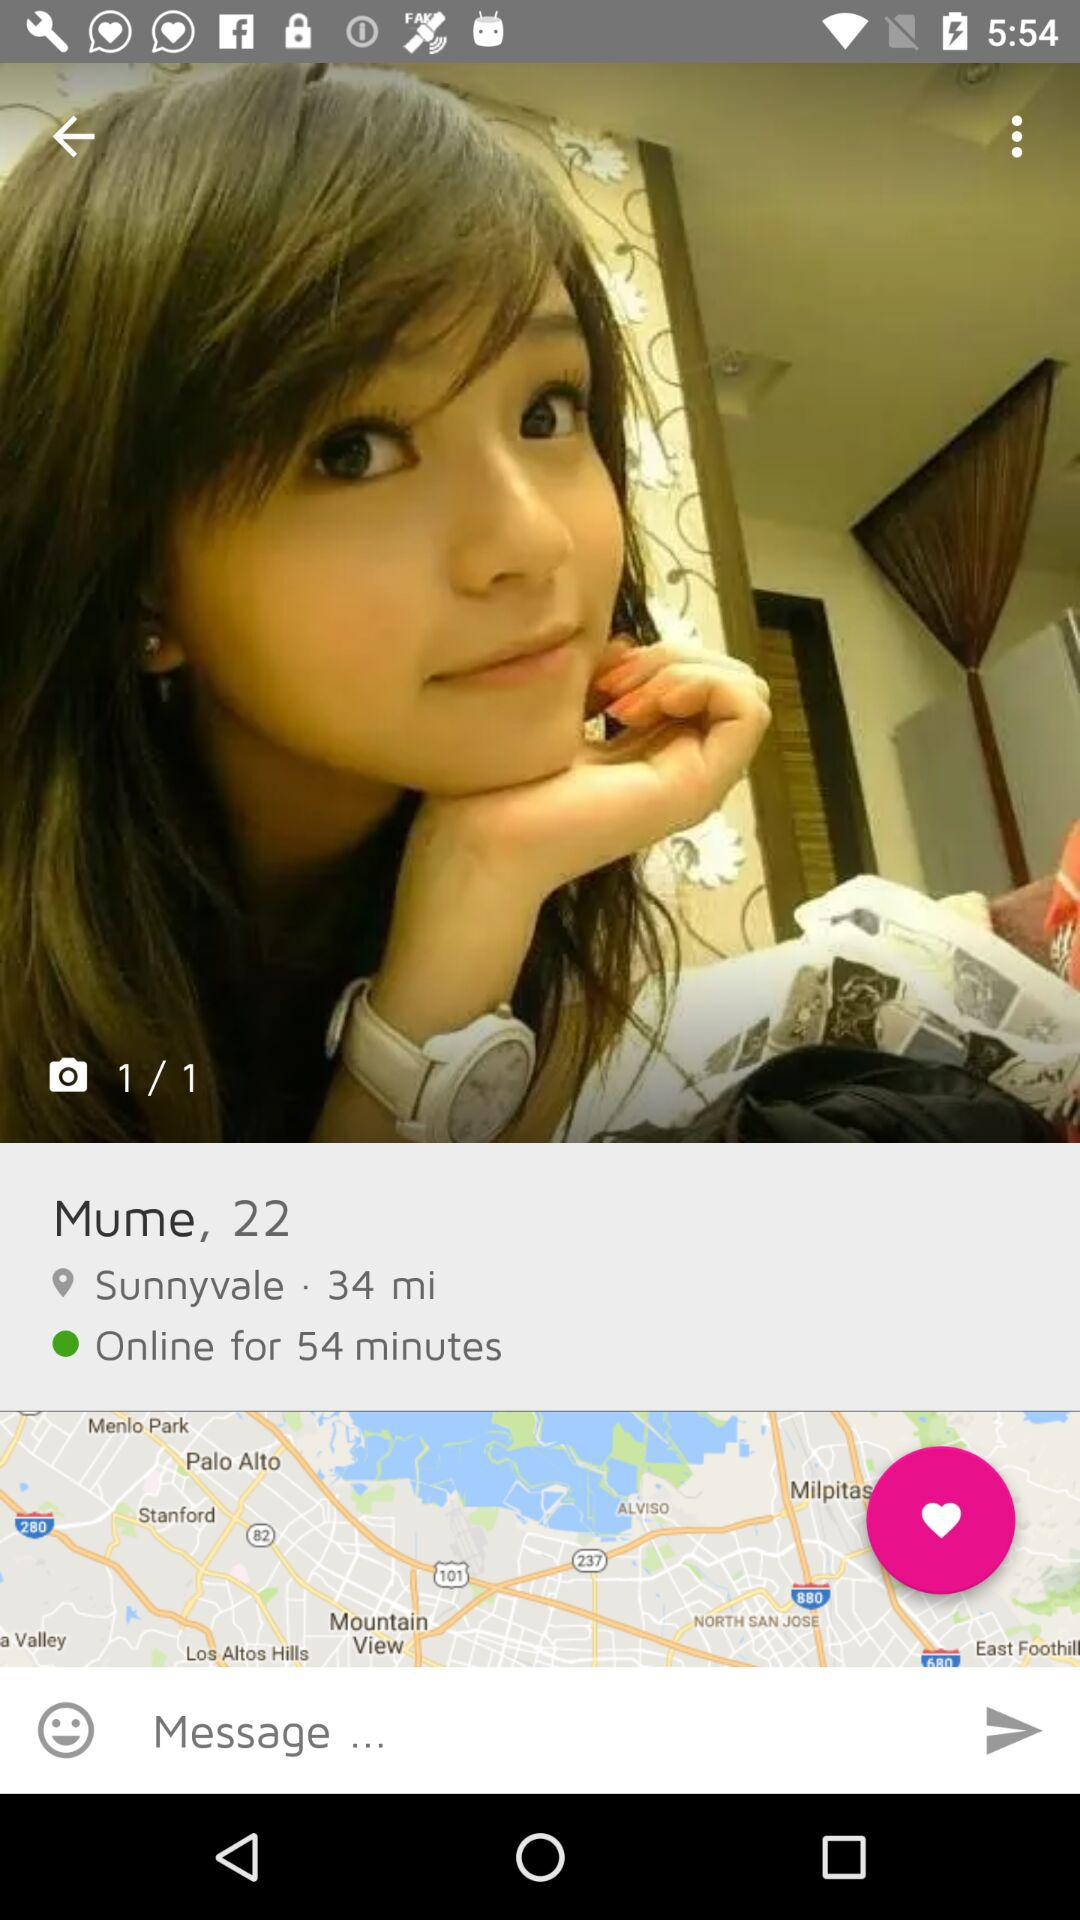What is the age? The age is 22 years. 